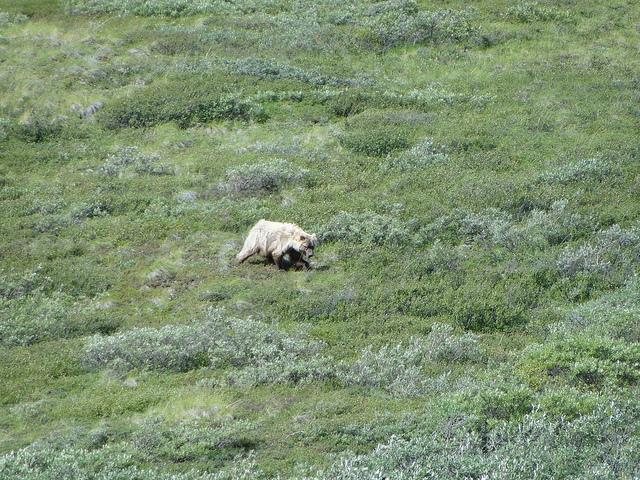How many cows are shown?
Give a very brief answer. 0. How many people have long hair?
Give a very brief answer. 0. 